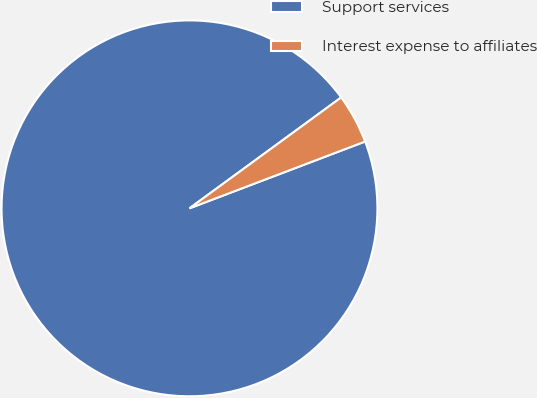Convert chart to OTSL. <chart><loc_0><loc_0><loc_500><loc_500><pie_chart><fcel>Support services<fcel>Interest expense to affiliates<nl><fcel>95.74%<fcel>4.26%<nl></chart> 